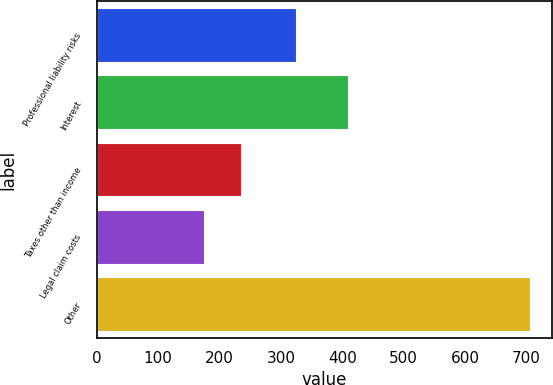Convert chart to OTSL. <chart><loc_0><loc_0><loc_500><loc_500><bar_chart><fcel>Professional liability risks<fcel>Interest<fcel>Taxes other than income<fcel>Legal claim costs<fcel>Other<nl><fcel>324<fcel>409<fcel>235<fcel>175<fcel>706<nl></chart> 